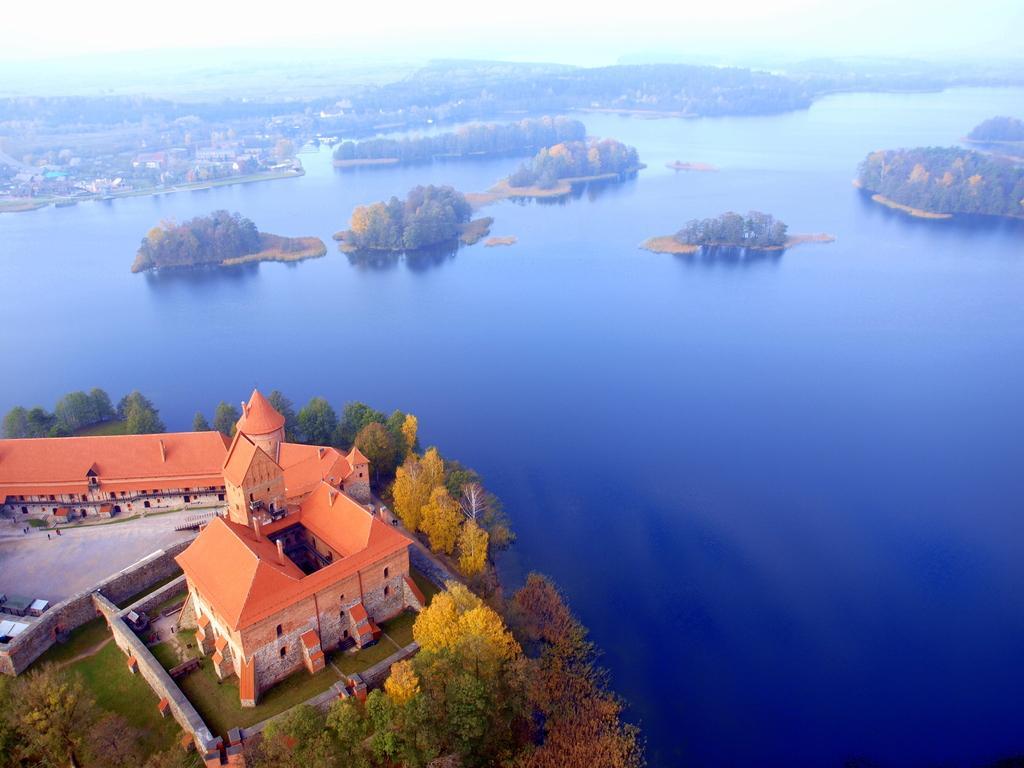How would you summarize this image in a sentence or two? In the foreground of this image, on the left, there are buildings, trees and the grass land. In the middle, there are trees in the water. In the background, there is greenery, few buildings and the sky. 